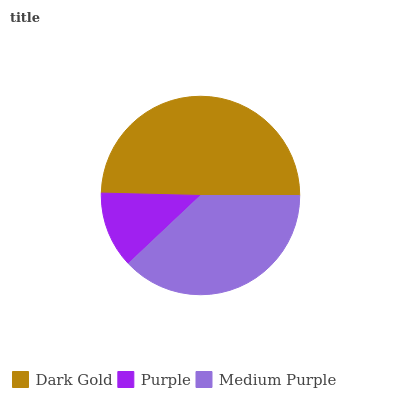Is Purple the minimum?
Answer yes or no. Yes. Is Dark Gold the maximum?
Answer yes or no. Yes. Is Medium Purple the minimum?
Answer yes or no. No. Is Medium Purple the maximum?
Answer yes or no. No. Is Medium Purple greater than Purple?
Answer yes or no. Yes. Is Purple less than Medium Purple?
Answer yes or no. Yes. Is Purple greater than Medium Purple?
Answer yes or no. No. Is Medium Purple less than Purple?
Answer yes or no. No. Is Medium Purple the high median?
Answer yes or no. Yes. Is Medium Purple the low median?
Answer yes or no. Yes. Is Purple the high median?
Answer yes or no. No. Is Purple the low median?
Answer yes or no. No. 